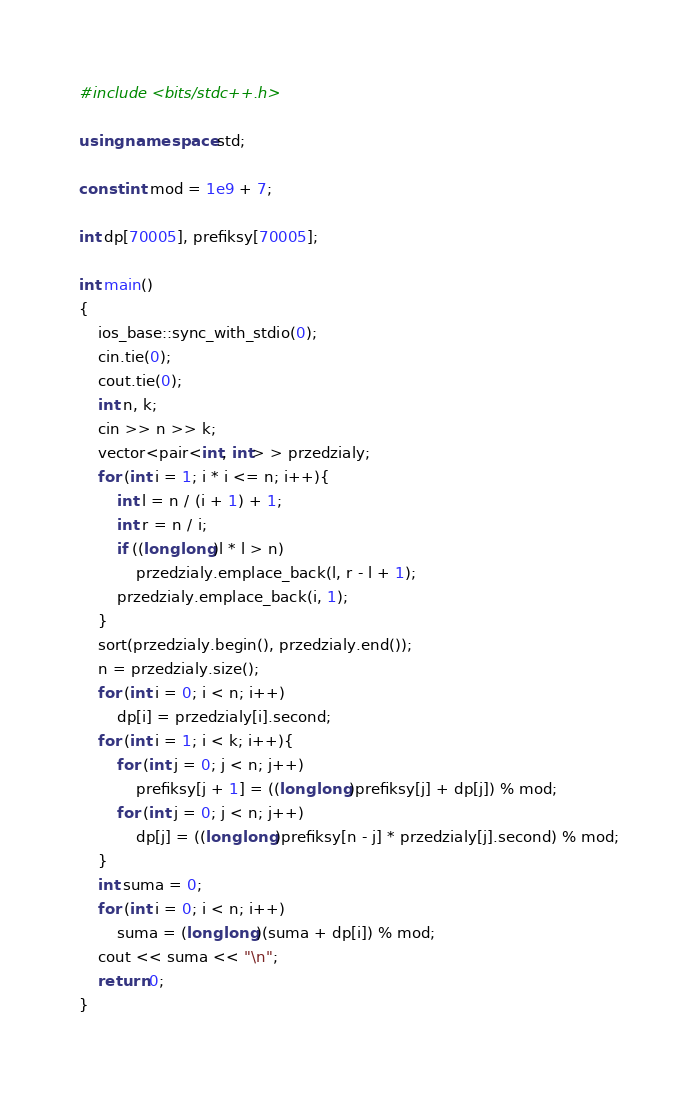<code> <loc_0><loc_0><loc_500><loc_500><_C++_>#include <bits/stdc++.h>

using namespace std;

const int mod = 1e9 + 7;

int dp[70005], prefiksy[70005];

int main()
{
    ios_base::sync_with_stdio(0);
    cin.tie(0);
    cout.tie(0);
    int n, k;
    cin >> n >> k;
    vector<pair<int, int> > przedzialy;
    for (int i = 1; i * i <= n; i++){
        int l = n / (i + 1) + 1;
        int r = n / i;
        if ((long long)l * l > n)
            przedzialy.emplace_back(l, r - l + 1);
        przedzialy.emplace_back(i, 1);
    }
    sort(przedzialy.begin(), przedzialy.end());
    n = przedzialy.size();
    for (int i = 0; i < n; i++)
        dp[i] = przedzialy[i].second;
    for (int i = 1; i < k; i++){
        for (int j = 0; j < n; j++)
            prefiksy[j + 1] = ((long long)prefiksy[j] + dp[j]) % mod;
        for (int j = 0; j < n; j++)
            dp[j] = ((long long)prefiksy[n - j] * przedzialy[j].second) % mod;
    }
    int suma = 0;
    for (int i = 0; i < n; i++)
        suma = (long long)(suma + dp[i]) % mod;
    cout << suma << "\n";
    return 0;
}</code> 